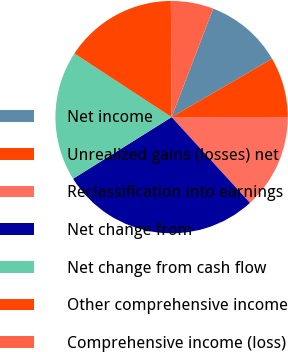Convert chart. <chart><loc_0><loc_0><loc_500><loc_500><pie_chart><fcel>Net income<fcel>Unrealized gains (losses) net<fcel>Reclassification into earnings<fcel>Net change from<fcel>Net change from cash flow<fcel>Other comprehensive income<fcel>Comprehensive income (loss)<nl><fcel>10.8%<fcel>8.36%<fcel>13.24%<fcel>27.89%<fcel>18.12%<fcel>15.68%<fcel>5.92%<nl></chart> 